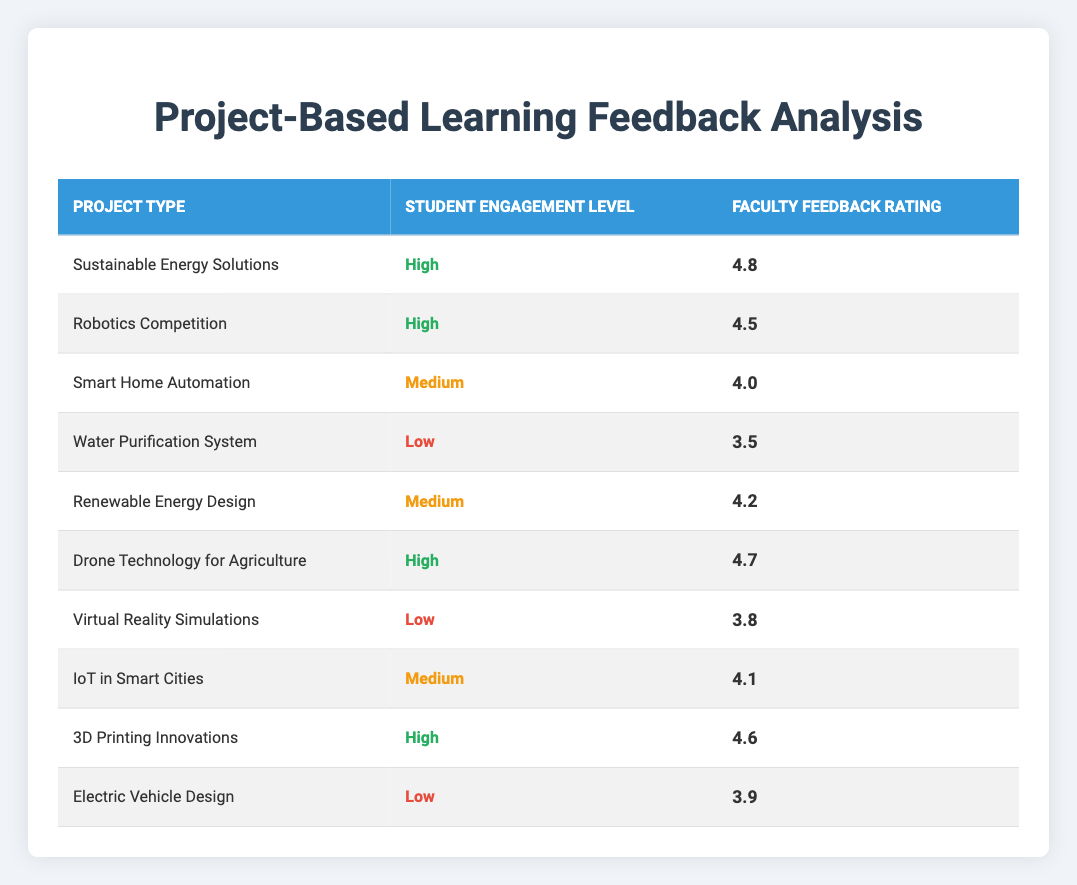What is the faculty feedback rating for the 'Drone Technology for Agriculture' project? The table lists 'Drone Technology for Agriculture' under the Project Type column, and the corresponding Faculty Feedback Rating in the table is 4.7.
Answer: 4.7 What is the engagement level of the 'Water Purification System' project? In the table, 'Water Purification System' has an entry in the Student Engagement Level column, showing it as 'Low'.
Answer: Low Which project type has the highest faculty feedback rating? The 'Sustainable Energy Solutions' project has the highest rating of 4.8 according to the table.
Answer: Sustainable Energy Solutions What is the average faculty feedback rating for projects with high student engagement? The ratings for high engagement projects (4.8, 4.5, 4.7, 4.6) sum to 18.6. With 4 projects, the average rating is 18.6/4 = 4.65.
Answer: 4.65 Is the faculty feedback rating for 'Smart Home Automation' higher than that of 'Virtual Reality Simulations'? 'Smart Home Automation' has a rating of 4.0, while 'Virtual Reality Simulations' has a rating of 3.8. Thus, 4.0 is greater than 3.8.
Answer: Yes What is the difference in faculty feedback ratings between the 'Renewable Energy Design' and 'Electric Vehicle Design' projects? The rating for 'Renewable Energy Design' is 4.2, and for 'Electric Vehicle Design' it is 3.9. The difference is 4.2 - 3.9 = 0.3.
Answer: 0.3 How many projects have a faculty feedback rating of 4.0 or higher? The projects listed with a rating of 4.0 or higher are: Sustainable Energy Solutions (4.8), Robotics Competition (4.5), Drone Technology for Agriculture (4.7), 3D Printing Innovations (4.6), Renewable Energy Design (4.2), IoT in Smart Cities (4.1). There are 6 such projects.
Answer: 6 Which project has a low student engagement level and the highest rating among them? The projects with a low engagement level listed are 'Water Purification System' (3.5), 'Virtual Reality Simulations' (3.8), and 'Electric Vehicle Design' (3.9). The highest rating among these is for 'Electric Vehicle Design' at 3.9.
Answer: Electric Vehicle Design What is the minimum faculty feedback rating across all project types? To find the minimum rating, we review the ratings: 4.8, 4.5, 4.0, 3.5, 4.2, 4.7, 3.8, 4.1, 4.6, and 3.9. The minimum is 3.5 associated with 'Water Purification System'.
Answer: 3.5 